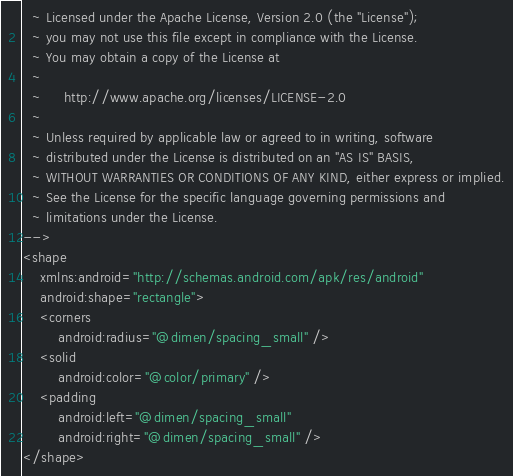Convert code to text. <code><loc_0><loc_0><loc_500><loc_500><_XML_>  ~ Licensed under the Apache License, Version 2.0 (the "License");
  ~ you may not use this file except in compliance with the License.
  ~ You may obtain a copy of the License at
  ~
  ~     http://www.apache.org/licenses/LICENSE-2.0
  ~
  ~ Unless required by applicable law or agreed to in writing, software
  ~ distributed under the License is distributed on an "AS IS" BASIS,
  ~ WITHOUT WARRANTIES OR CONDITIONS OF ANY KIND, either express or implied.
  ~ See the License for the specific language governing permissions and
  ~ limitations under the License.
-->
<shape
    xmlns:android="http://schemas.android.com/apk/res/android"
    android:shape="rectangle">
    <corners
        android:radius="@dimen/spacing_small" />
    <solid
        android:color="@color/primary" />
    <padding
        android:left="@dimen/spacing_small"
        android:right="@dimen/spacing_small" />
</shape>
</code> 